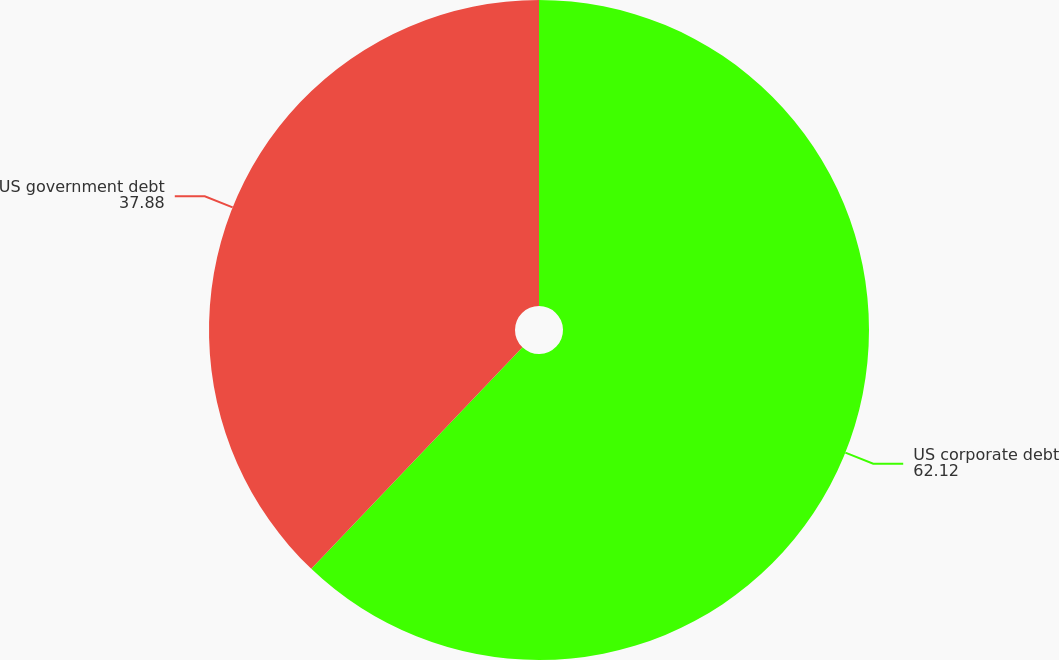<chart> <loc_0><loc_0><loc_500><loc_500><pie_chart><fcel>US corporate debt<fcel>US government debt<nl><fcel>62.12%<fcel>37.88%<nl></chart> 